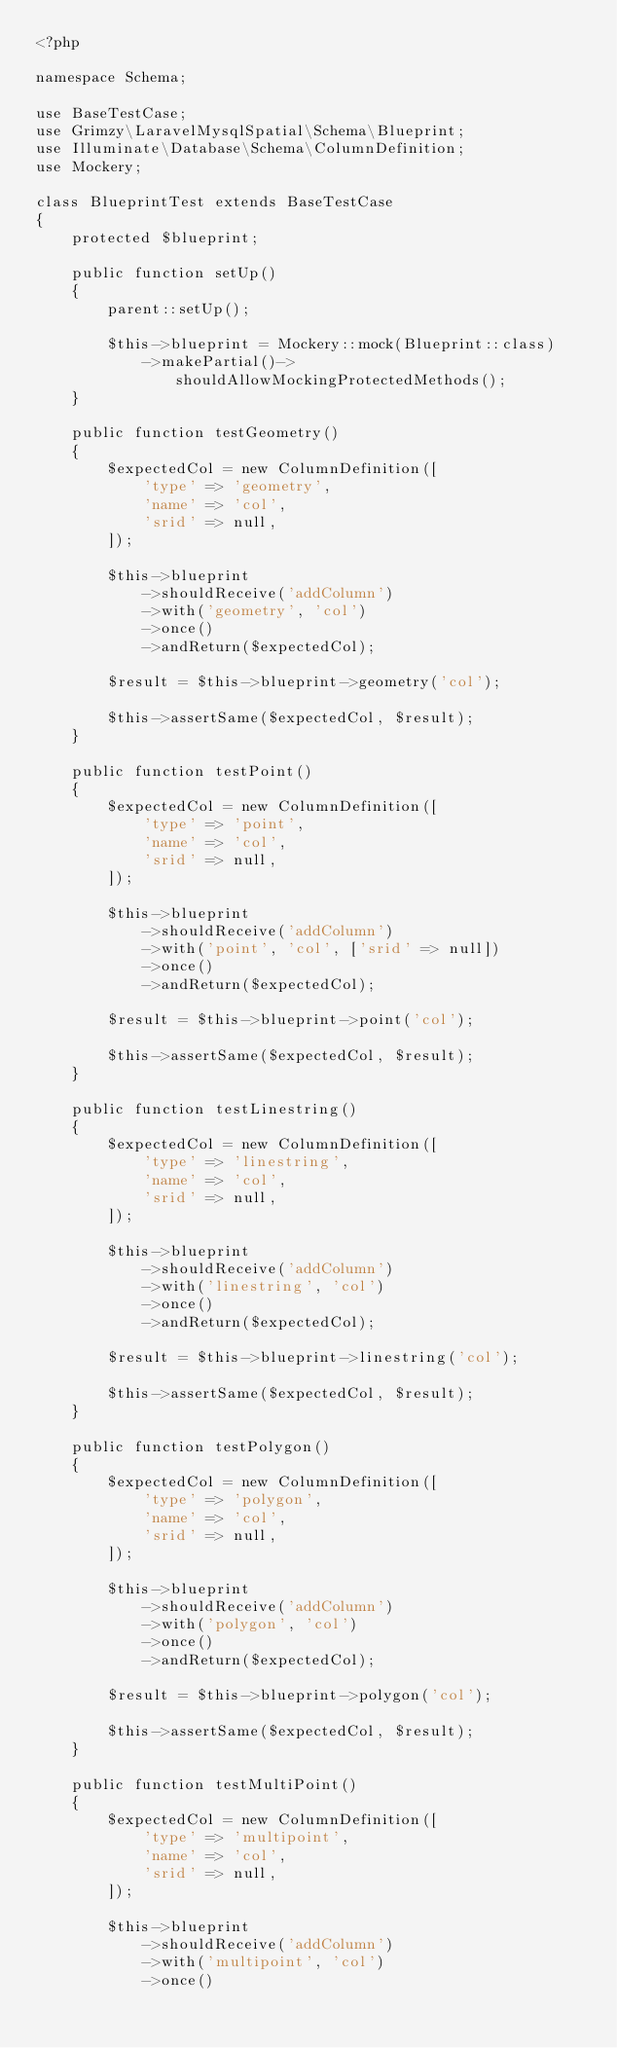<code> <loc_0><loc_0><loc_500><loc_500><_PHP_><?php

namespace Schema;

use BaseTestCase;
use Grimzy\LaravelMysqlSpatial\Schema\Blueprint;
use Illuminate\Database\Schema\ColumnDefinition;
use Mockery;

class BlueprintTest extends BaseTestCase
{
    protected $blueprint;

    public function setUp()
    {
        parent::setUp();

        $this->blueprint = Mockery::mock(Blueprint::class)
            ->makePartial()->shouldAllowMockingProtectedMethods();
    }

    public function testGeometry()
    {
        $expectedCol = new ColumnDefinition([
            'type' => 'geometry',
            'name' => 'col',
            'srid' => null,
        ]);

        $this->blueprint
            ->shouldReceive('addColumn')
            ->with('geometry', 'col')
            ->once()
            ->andReturn($expectedCol);

        $result = $this->blueprint->geometry('col');

        $this->assertSame($expectedCol, $result);
    }

    public function testPoint()
    {
        $expectedCol = new ColumnDefinition([
            'type' => 'point',
            'name' => 'col',
            'srid' => null,
        ]);

        $this->blueprint
            ->shouldReceive('addColumn')
            ->with('point', 'col', ['srid' => null])
            ->once()
            ->andReturn($expectedCol);

        $result = $this->blueprint->point('col');

        $this->assertSame($expectedCol, $result);
    }

    public function testLinestring()
    {
        $expectedCol = new ColumnDefinition([
            'type' => 'linestring',
            'name' => 'col',
            'srid' => null,
        ]);

        $this->blueprint
            ->shouldReceive('addColumn')
            ->with('linestring', 'col')
            ->once()
            ->andReturn($expectedCol);

        $result = $this->blueprint->linestring('col');

        $this->assertSame($expectedCol, $result);
    }

    public function testPolygon()
    {
        $expectedCol = new ColumnDefinition([
            'type' => 'polygon',
            'name' => 'col',
            'srid' => null,
        ]);

        $this->blueprint
            ->shouldReceive('addColumn')
            ->with('polygon', 'col')
            ->once()
            ->andReturn($expectedCol);

        $result = $this->blueprint->polygon('col');

        $this->assertSame($expectedCol, $result);
    }

    public function testMultiPoint()
    {
        $expectedCol = new ColumnDefinition([
            'type' => 'multipoint',
            'name' => 'col',
            'srid' => null,
        ]);

        $this->blueprint
            ->shouldReceive('addColumn')
            ->with('multipoint', 'col')
            ->once()</code> 